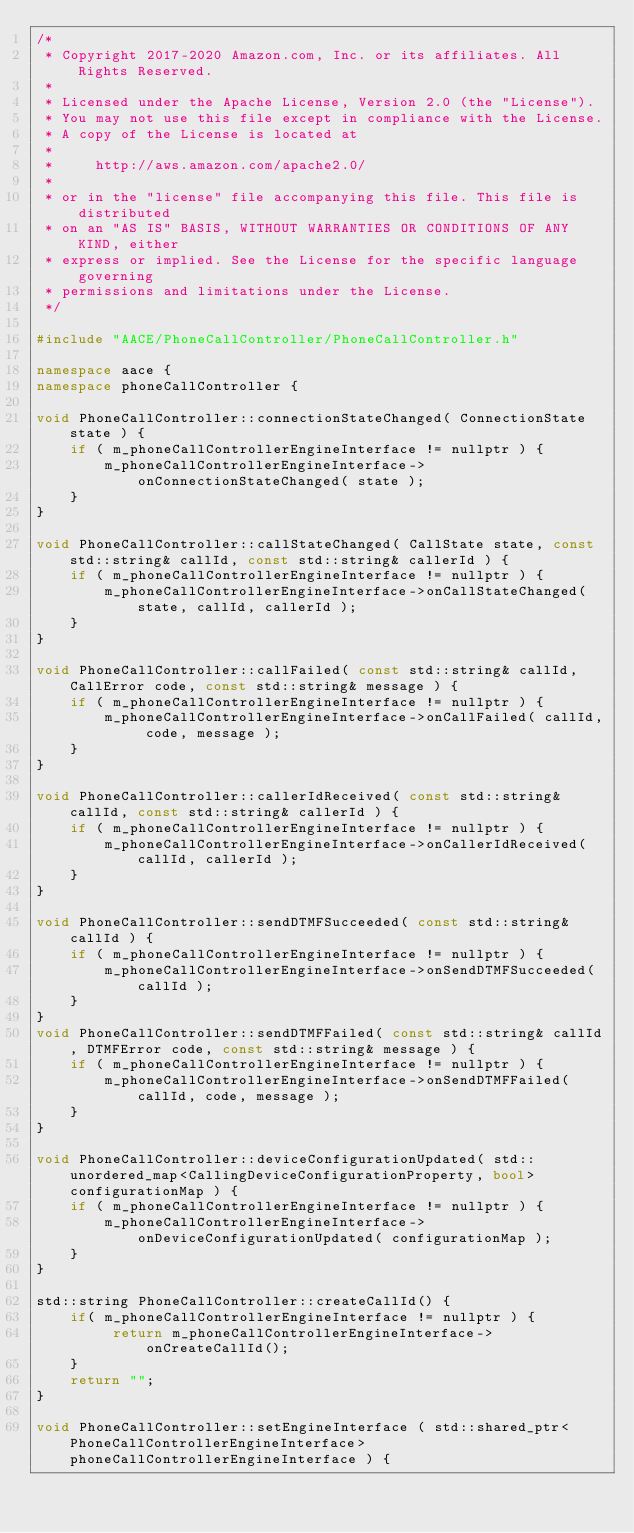Convert code to text. <code><loc_0><loc_0><loc_500><loc_500><_C++_>/*
 * Copyright 2017-2020 Amazon.com, Inc. or its affiliates. All Rights Reserved.
 *
 * Licensed under the Apache License, Version 2.0 (the "License").
 * You may not use this file except in compliance with the License.
 * A copy of the License is located at
 *
 *     http://aws.amazon.com/apache2.0/
 *
 * or in the "license" file accompanying this file. This file is distributed
 * on an "AS IS" BASIS, WITHOUT WARRANTIES OR CONDITIONS OF ANY KIND, either
 * express or implied. See the License for the specific language governing
 * permissions and limitations under the License.
 */

#include "AACE/PhoneCallController/PhoneCallController.h"

namespace aace {
namespace phoneCallController {

void PhoneCallController::connectionStateChanged( ConnectionState state ) {
    if ( m_phoneCallControllerEngineInterface != nullptr ) {
        m_phoneCallControllerEngineInterface->onConnectionStateChanged( state );
    }
}

void PhoneCallController::callStateChanged( CallState state, const std::string& callId, const std::string& callerId ) {
    if ( m_phoneCallControllerEngineInterface != nullptr ) {
        m_phoneCallControllerEngineInterface->onCallStateChanged( state, callId, callerId );
    }
}

void PhoneCallController::callFailed( const std::string& callId, CallError code, const std::string& message ) {
    if ( m_phoneCallControllerEngineInterface != nullptr ) {
        m_phoneCallControllerEngineInterface->onCallFailed( callId, code, message );
    }
}

void PhoneCallController::callerIdReceived( const std::string& callId, const std::string& callerId ) {
    if ( m_phoneCallControllerEngineInterface != nullptr ) {
        m_phoneCallControllerEngineInterface->onCallerIdReceived( callId, callerId );
    }
}

void PhoneCallController::sendDTMFSucceeded( const std::string& callId ) {
    if ( m_phoneCallControllerEngineInterface != nullptr ) {
        m_phoneCallControllerEngineInterface->onSendDTMFSucceeded( callId );
    }
}
void PhoneCallController::sendDTMFFailed( const std::string& callId, DTMFError code, const std::string& message ) {
    if ( m_phoneCallControllerEngineInterface != nullptr ) {
        m_phoneCallControllerEngineInterface->onSendDTMFFailed( callId, code, message );
    }
}

void PhoneCallController::deviceConfigurationUpdated( std::unordered_map<CallingDeviceConfigurationProperty, bool> configurationMap ) {
    if ( m_phoneCallControllerEngineInterface != nullptr ) {
        m_phoneCallControllerEngineInterface->onDeviceConfigurationUpdated( configurationMap );
    }
}

std::string PhoneCallController::createCallId() {
    if( m_phoneCallControllerEngineInterface != nullptr ) {
         return m_phoneCallControllerEngineInterface->onCreateCallId();
    }
    return "";
}

void PhoneCallController::setEngineInterface ( std::shared_ptr<PhoneCallControllerEngineInterface>  phoneCallControllerEngineInterface ) {</code> 